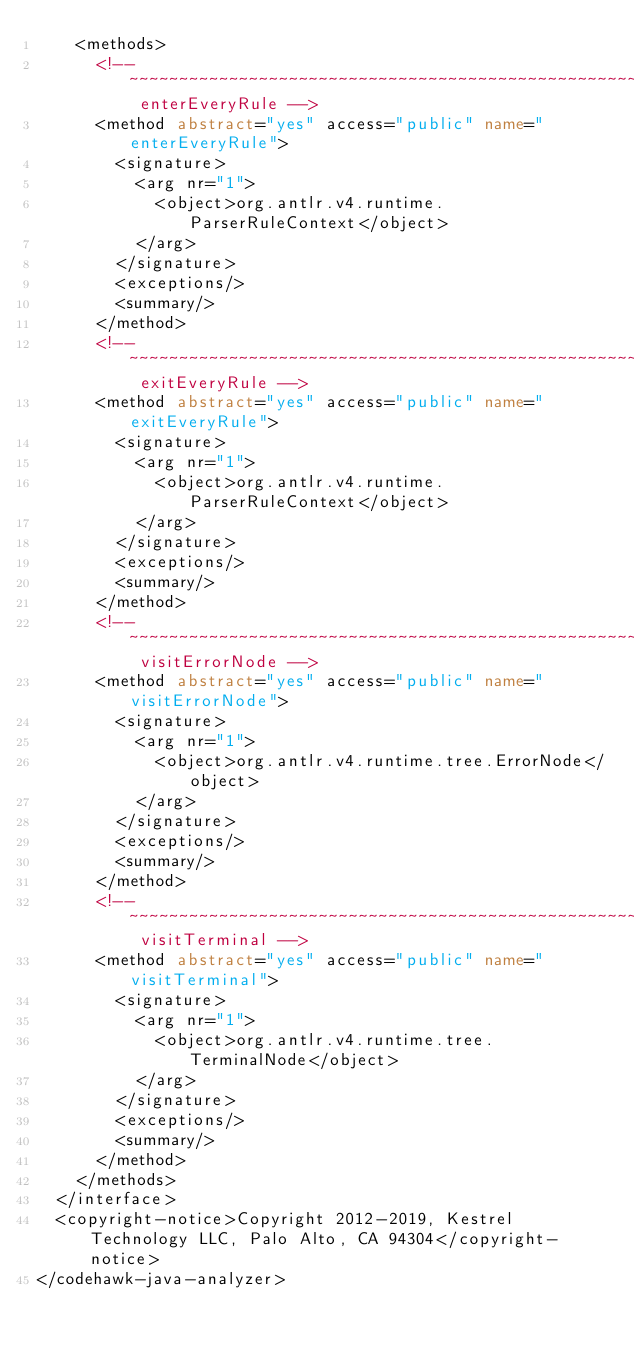Convert code to text. <code><loc_0><loc_0><loc_500><loc_500><_XML_>    <methods>
      <!-- ~~~~~~~~~~~~~~~~~~~~~~~~~~~~~~~~~~~~~~~~~~~~~~~~~~~~~~ enterEveryRule -->
      <method abstract="yes" access="public" name="enterEveryRule">
        <signature>
          <arg nr="1">
            <object>org.antlr.v4.runtime.ParserRuleContext</object>
          </arg>
        </signature>
        <exceptions/>
        <summary/>
      </method>
      <!-- ~~~~~~~~~~~~~~~~~~~~~~~~~~~~~~~~~~~~~~~~~~~~~~~~~~~~~~~ exitEveryRule -->
      <method abstract="yes" access="public" name="exitEveryRule">
        <signature>
          <arg nr="1">
            <object>org.antlr.v4.runtime.ParserRuleContext</object>
          </arg>
        </signature>
        <exceptions/>
        <summary/>
      </method>
      <!-- ~~~~~~~~~~~~~~~~~~~~~~~~~~~~~~~~~~~~~~~~~~~~~~~~~~~~~~ visitErrorNode -->
      <method abstract="yes" access="public" name="visitErrorNode">
        <signature>
          <arg nr="1">
            <object>org.antlr.v4.runtime.tree.ErrorNode</object>
          </arg>
        </signature>
        <exceptions/>
        <summary/>
      </method>
      <!-- ~~~~~~~~~~~~~~~~~~~~~~~~~~~~~~~~~~~~~~~~~~~~~~~~~~~~~~~ visitTerminal -->
      <method abstract="yes" access="public" name="visitTerminal">
        <signature>
          <arg nr="1">
            <object>org.antlr.v4.runtime.tree.TerminalNode</object>
          </arg>
        </signature>
        <exceptions/>
        <summary/>
      </method>
    </methods>
  </interface>
  <copyright-notice>Copyright 2012-2019, Kestrel Technology LLC, Palo Alto, CA 94304</copyright-notice>
</codehawk-java-analyzer>
</code> 